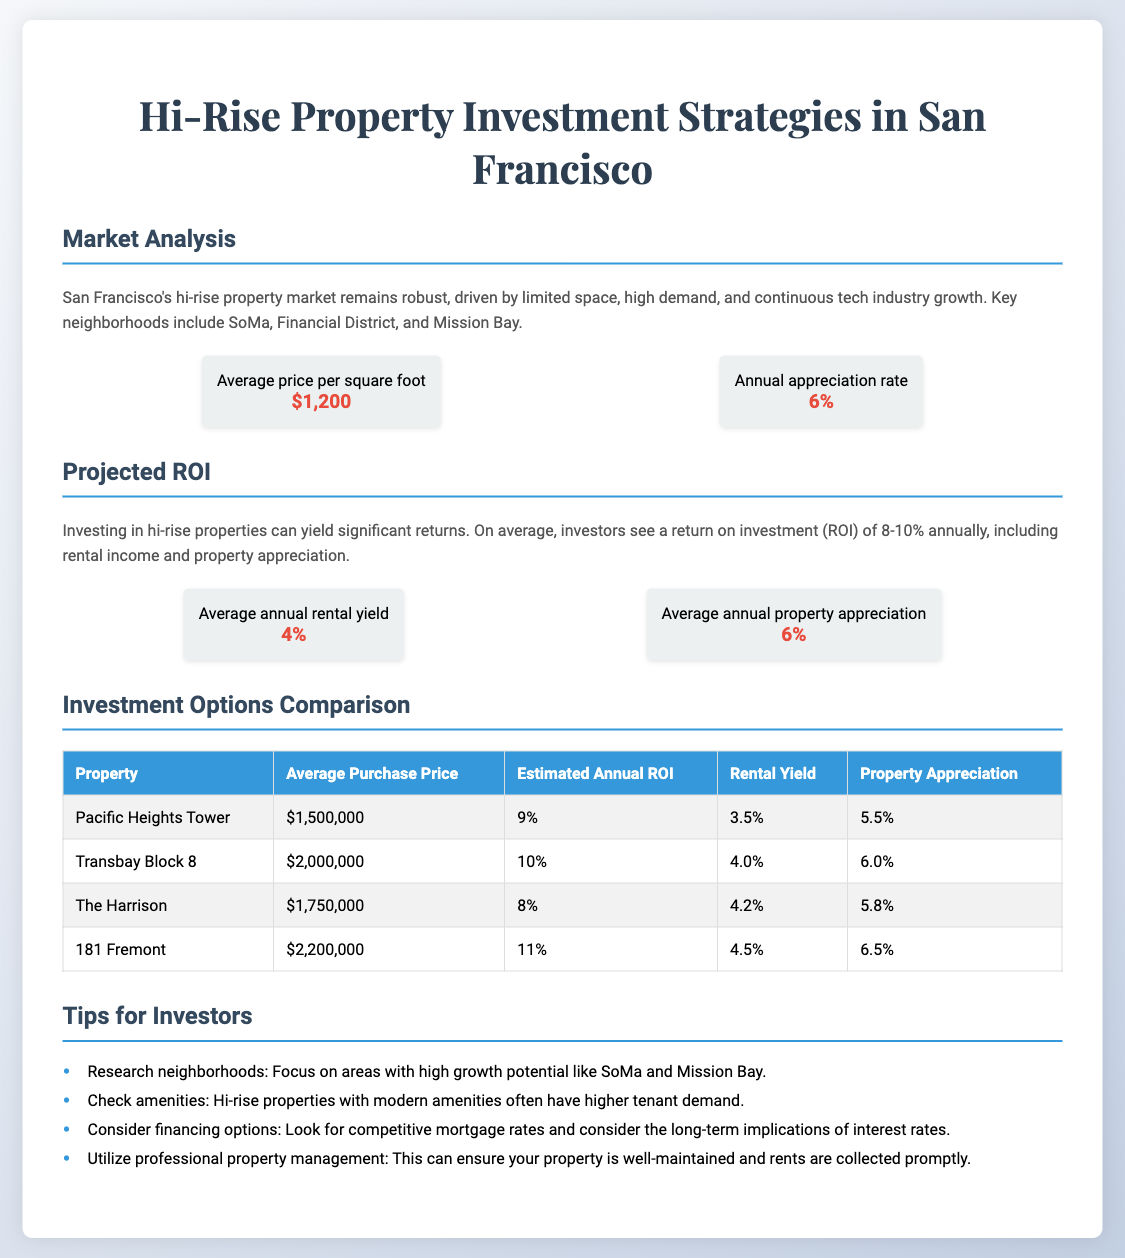What is the average price per square foot? The average price per square foot mentioned in the document is $1,200.
Answer: $1,200 What is the annual appreciation rate? The document states the annual appreciation rate is 6%.
Answer: 6% What is the average purchase price of Transbay Block 8? The average purchase price for Transbay Block 8 is listed as $2,000,000.
Answer: $2,000,000 Which neighborhood is highlighted for its growth potential? The document mentions SoMa as a neighborhood with high growth potential.
Answer: SoMa What is the estimated annual ROI for 181 Fremont? The document indicates that the estimated annual ROI for 181 Fremont is 11%.
Answer: 11% What is the average annual rental yield? The average annual rental yield noted in the document is 4%.
Answer: 4% What type of properties are compared in the investment options section? The investment options section compares hi-rise properties.
Answer: Hi-rise properties What should investors check for higher tenant demand? Investors are advised to check amenities in the properties.
Answer: Amenities What is one of the tips for investors mentioned? One of the tips provided in the document is to research neighborhoods.
Answer: Research neighborhoods 